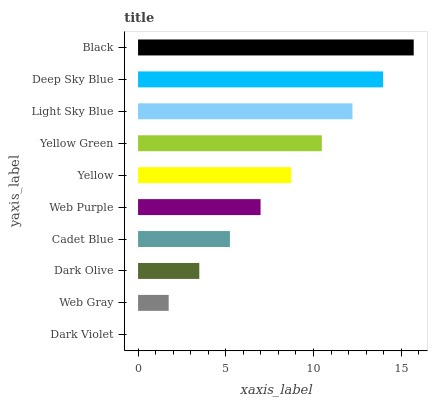Is Dark Violet the minimum?
Answer yes or no. Yes. Is Black the maximum?
Answer yes or no. Yes. Is Web Gray the minimum?
Answer yes or no. No. Is Web Gray the maximum?
Answer yes or no. No. Is Web Gray greater than Dark Violet?
Answer yes or no. Yes. Is Dark Violet less than Web Gray?
Answer yes or no. Yes. Is Dark Violet greater than Web Gray?
Answer yes or no. No. Is Web Gray less than Dark Violet?
Answer yes or no. No. Is Yellow the high median?
Answer yes or no. Yes. Is Web Purple the low median?
Answer yes or no. Yes. Is Web Purple the high median?
Answer yes or no. No. Is Dark Olive the low median?
Answer yes or no. No. 